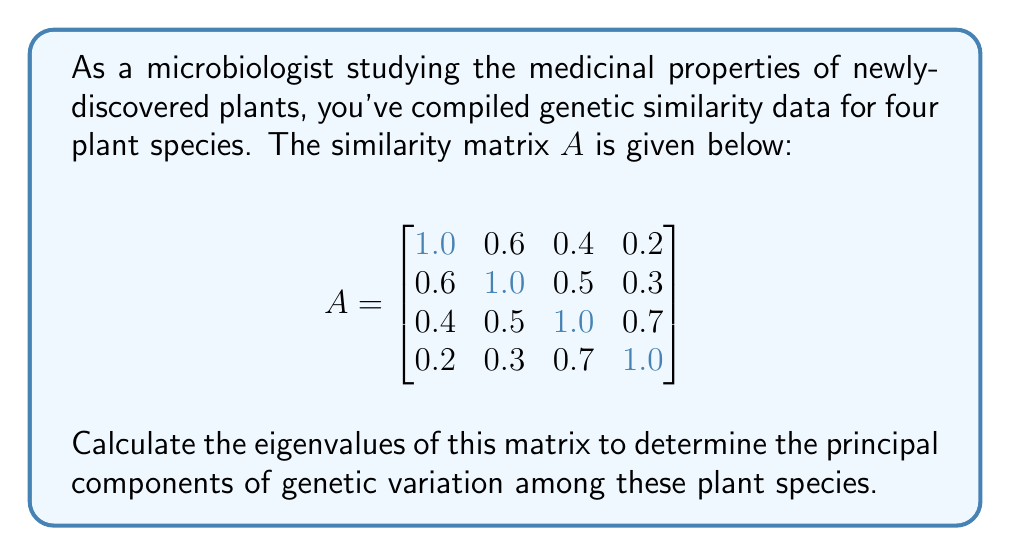Give your solution to this math problem. To find the eigenvalues of matrix $A$, we need to solve the characteristic equation:

1) First, we set up the equation $\det(A - \lambda I) = 0$, where $I$ is the 4x4 identity matrix and $\lambda$ represents the eigenvalues.

2) Expanding this, we get:

   $$\begin{vmatrix}
   1-\lambda & 0.6 & 0.4 & 0.2 \\
   0.6 & 1-\lambda & 0.5 & 0.3 \\
   0.4 & 0.5 & 1-\lambda & 0.7 \\
   0.2 & 0.3 & 0.7 & 1-\lambda
   \end{vmatrix} = 0$$

3) Calculating this determinant (which is a complex process, often done with computer assistance), we arrive at the characteristic polynomial:

   $\lambda^4 - 4\lambda^3 + 3.51\lambda^2 - 0.884\lambda + 0.0369 = 0$

4) The roots of this polynomial are the eigenvalues. Solving this equation (typically using numerical methods), we get the following eigenvalues:

   $\lambda_1 \approx 2.6477$
   $\lambda_2 \approx 0.8184$
   $\lambda_3 \approx 0.3553$
   $\lambda_4 \approx 0.1786$

These eigenvalues represent the amount of variance explained by each principal component of genetic variation among the plant species.
Answer: $\lambda_1 \approx 2.6477$, $\lambda_2 \approx 0.8184$, $\lambda_3 \approx 0.3553$, $\lambda_4 \approx 0.1786$ 